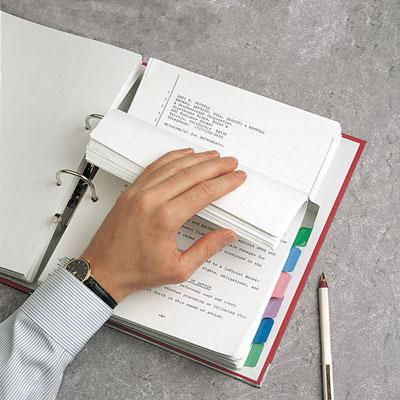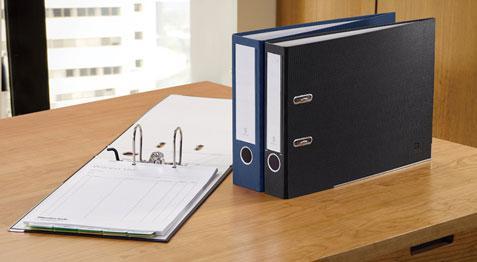The first image is the image on the left, the second image is the image on the right. Analyze the images presented: Is the assertion "An open ring binder with papers in it lies flat next to at least two upright closed binders." valid? Answer yes or no. Yes. The first image is the image on the left, the second image is the image on the right. Evaluate the accuracy of this statement regarding the images: "A binder is on top of a desk.". Is it true? Answer yes or no. Yes. 